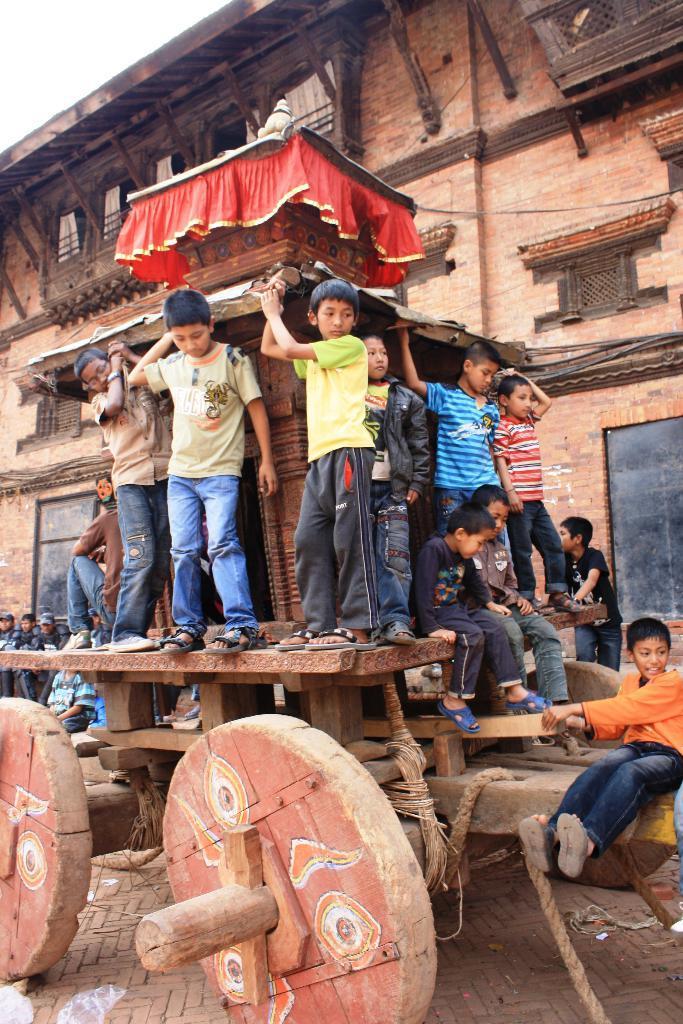Could you give a brief overview of what you see in this image? Here we can see group of people and there is a cart. In the background we can see a building. 